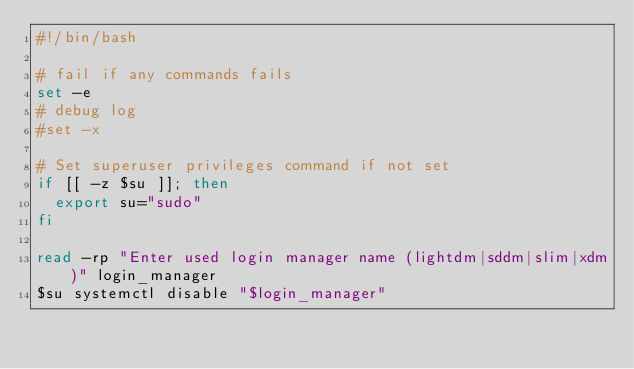Convert code to text. <code><loc_0><loc_0><loc_500><loc_500><_Bash_>#!/bin/bash

# fail if any commands fails
set -e
# debug log
#set -x

# Set superuser privileges command if not set
if [[ -z $su ]]; then
  export su="sudo"
fi

read -rp "Enter used login manager name (lightdm|sddm|slim|xdm)" login_manager
$su systemctl disable "$login_manager"</code> 